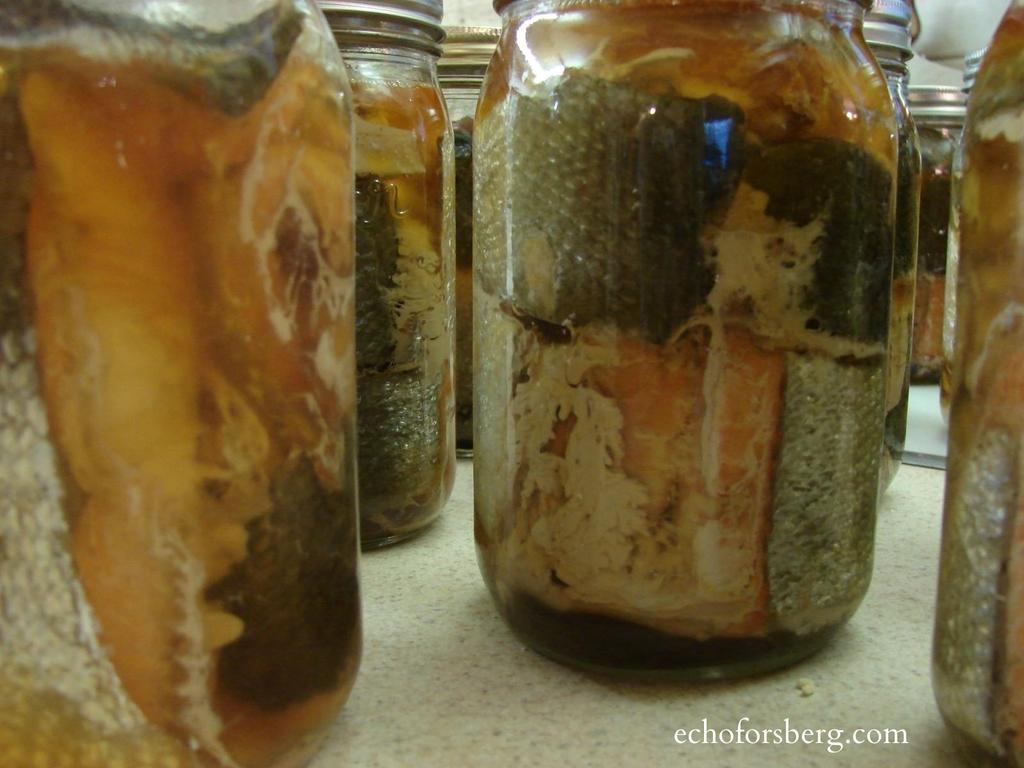What objects are present in the image? There are bottles in the image. What is inside the bottles? The bottles contain something inside them. Can you describe any other details in the image? There is a water mark in the right corner of the image. What type of wire is being used to fly the plane in the image? There is no wire or plane present in the image; it only features bottles and a water mark. 